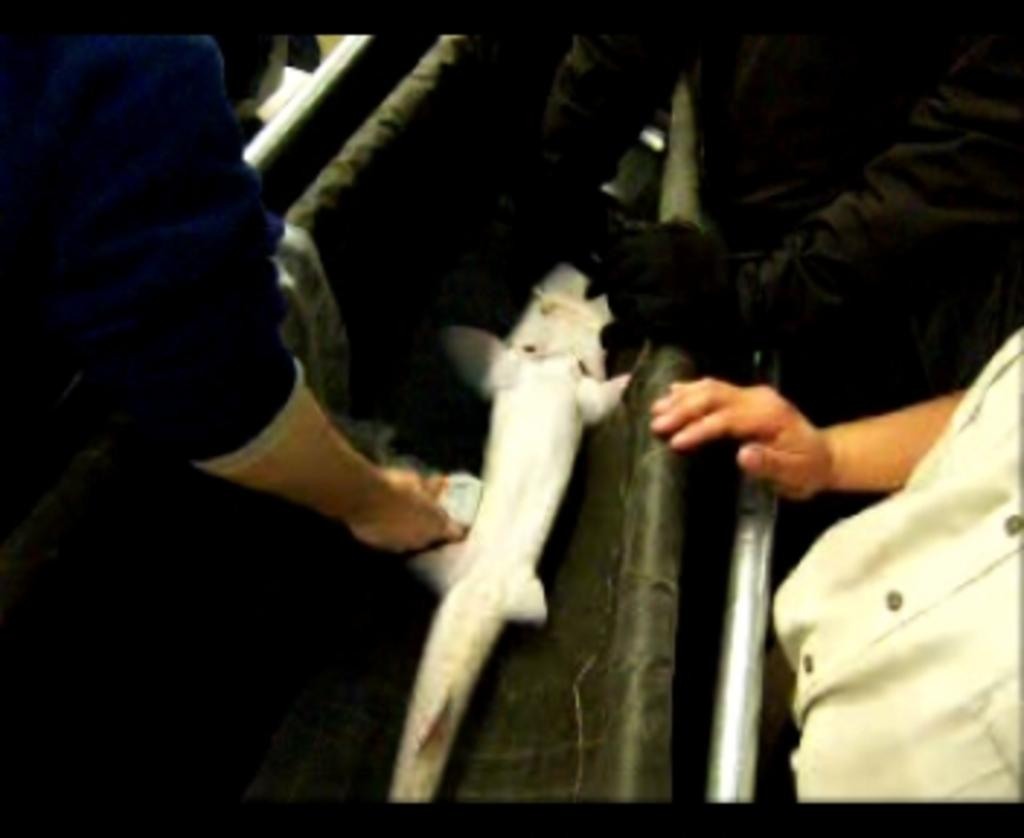What type of creature is in the image? There is an animal in the image. Where is the animal located? The animal is in a box. Who is interacting with the animal? There are people holding the animal. What is the position of the person near the box? There is a person with their hand on the box. How does the animal maintain its balance while inside the box? The animal does not need to maintain its balance while inside the box, as it is being held by people. Is there a kitten visible in the image? There is no mention of a kitten in the provided facts, so we cannot determine if one is present in the image. 